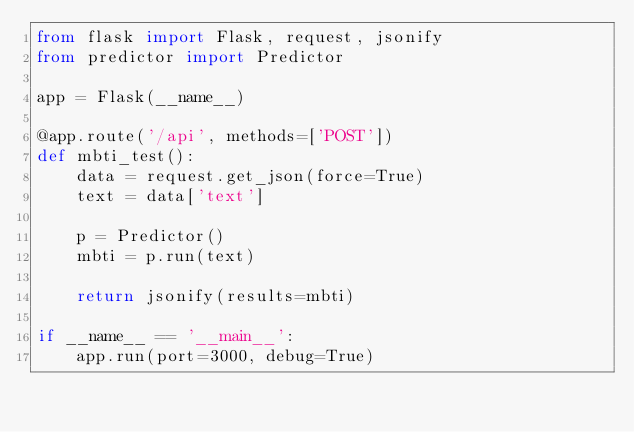<code> <loc_0><loc_0><loc_500><loc_500><_Python_>from flask import Flask, request, jsonify
from predictor import Predictor

app = Flask(__name__)

@app.route('/api', methods=['POST'])
def mbti_test():
    data = request.get_json(force=True)
    text = data['text']
    
    p = Predictor()
    mbti = p.run(text)
    
    return jsonify(results=mbti)

if __name__ == '__main__':
    app.run(port=3000, debug=True)</code> 